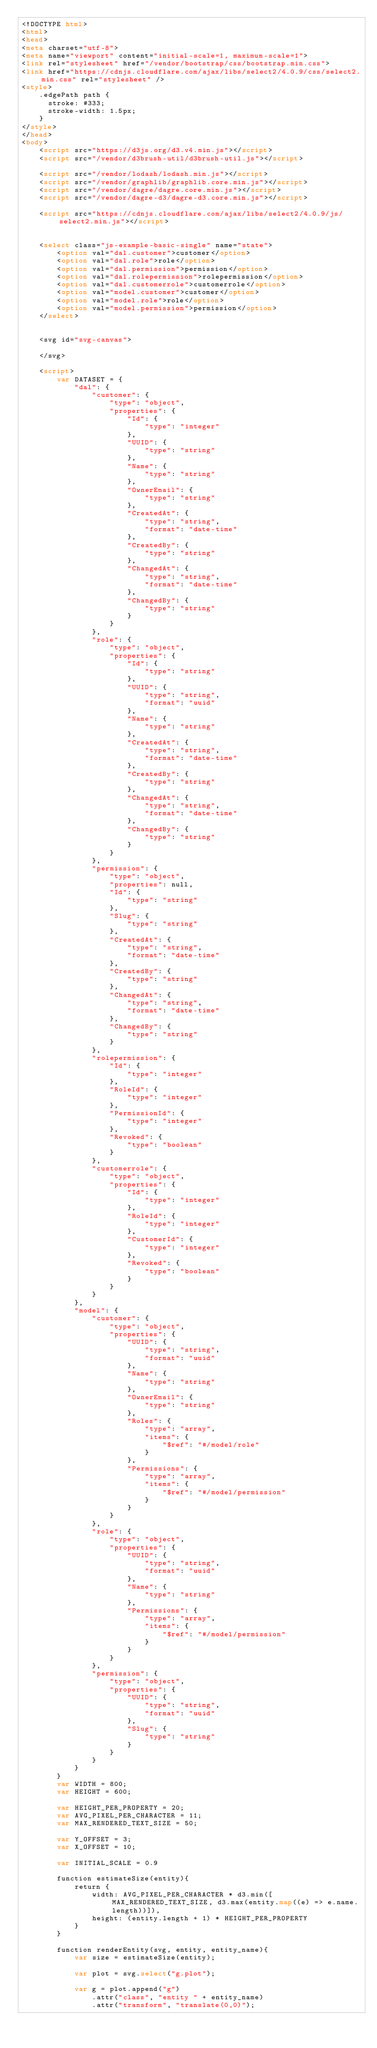<code> <loc_0><loc_0><loc_500><loc_500><_HTML_><!DOCTYPE html>
<html>
<head>
<meta charset="utf-8">
<meta name="viewport" content="initial-scale=1, maximum-scale=1">
<link rel="stylesheet" href="/vendor/bootstrap/css/bootstrap.min.css">
<link href="https://cdnjs.cloudflare.com/ajax/libs/select2/4.0.9/css/select2.min.css" rel="stylesheet" />
<style>
	.edgePath path {
	  stroke: #333;
	  stroke-width: 1.5px;
	}
</style>
</head>
<body>
	<script src="https://d3js.org/d3.v4.min.js"></script>
	<script src="/vendor/d3brush-util/d3brush-util.js"></script>

	<script src="/vendor/lodash/lodash.min.js"></script>
	<script src="/vendor/graphlib/graphlib.core.min.js"></script>
	<script src="/vendor/dagre/dagre.core.min.js"></script>
	<script src="/vendor/dagre-d3/dagre-d3.core.min.js"></script>

	<script src="https://cdnjs.cloudflare.com/ajax/libs/select2/4.0.9/js/select2.min.js"></script>


	<select class="js-example-basic-single" name="state">
		<option val="dal.customer">customer</option>
		<option val="dal.role">role</option>
		<option val="dal.permission">permission</option>
		<option val="dal.rolepermission">rolepermission</option>
		<option val="dal.customerrole">customerrole</option>
		<option val="model.customer">customer</option>
		<option val="model.role">role</option>
		<option val="model.permission">permission</option>
	</select>

	
	<svg id="svg-canvas">
		
	</svg>
	
	<script>
		var DATASET = {
		    "dal": {
		        "customer": {
		            "type": "object",
		            "properties": {
		                "Id": {
		                    "type": "integer"
		                },
		                "UUID": {
		                    "type": "string"
		                },
		                "Name": {
		                    "type": "string"
		                },
		                "OwnerEmail": {
		                    "type": "string"
		                },
		                "CreatedAt": {
		                    "type": "string",
		                    "format": "date-time"
		                },
		                "CreatedBy": {
		                    "type": "string"
		                },
		                "ChangedAt": {
		                    "type": "string",
		                    "format": "date-time"
		                },
		                "ChangedBy": {
		                    "type": "string"
		                }
		            }
		        },
		        "role": {
		            "type": "object",
		            "properties": {
		                "Id": {
		                    "type": "string"
		                },
		                "UUID": {
		                    "type": "string",
		                    "format": "uuid"
		                },
		                "Name": {
		                    "type": "string"
		                },
		                "CreatedAt": {
		                    "type": "string",
		                    "format": "date-time"
		                },
		                "CreatedBy": {
		                    "type": "string"
		                },
		                "ChangedAt": {
		                    "type": "string",
		                    "format": "date-time"
		                },
		                "ChangedBy": {
		                    "type": "string"
		                }
		            }
		        },
		        "permission": {
		            "type": "object",
		            "properties": null,
		            "Id": {
		                "type": "string"
		            },
		            "Slug": {
		                "type": "string"
		            },
		            "CreatedAt": {
		                "type": "string",
		                "format": "date-time"
		            },
		            "CreatedBy": {
		                "type": "string"
		            },
		            "ChangedAt": {
		                "type": "string",
		                "format": "date-time"
		            },
		            "ChangedBy": {
		                "type": "string"
		            }
		        },
		        "rolepermission": {
		            "Id": {
		                "type": "integer"
		            },
		            "RoleId": {
		                "type": "integer"
		            },
		            "PermissionId": {
		                "type": "integer"
		            },
		            "Revoked": {
		                "type": "boolean"
		            }
		        },
		        "customerrole": {
		            "type": "object",
		            "properties": {
		                "Id": {
		                    "type": "integer"
		                },
		                "RoleId": {
		                    "type": "integer"
		                },
		                "CustomerId": {
		                    "type": "integer"
		                },
		                "Revoked": {
		                    "type": "boolean"
		                }
		            }
		        }
		    },
		    "model": {
		        "customer": {
		            "type": "object",
		            "properties": {
		                "UUID": {
		                    "type": "string",
		                    "format": "uuid"
		                },
		                "Name": {
		                    "type": "string"
		                },
		                "OwnerEmail": {
		                    "type": "string"
		                },
		                "Roles": {
		                    "type": "array",
		                    "items": {
		                        "$ref": "#/model/role"
		                    }
		                },
		                "Permissions": {
		                    "type": "array",
		                    "items": {
		                        "$ref": "#/model/permission"
		                    }
		                }
		            }
		        },
		        "role": {
		            "type": "object",
		            "properties": {
		                "UUID": {
		                    "type": "string",
		                    "format": "uuid"
		                },
		                "Name": {
		                    "type": "string"
		                },
		                "Permissions": {
		                    "type": "array",
		                    "items": {
		                        "$ref": "#/model/permission"
		                    }
		                }
		            }
		        },
		        "permission": {
		            "type": "object",
		            "properties": {
		                "UUID": {
		                    "type": "string",
		                    "format": "uuid"
		                },
		                "Slug": {
		                    "type": "string"
		                }
		            }
		        }
		    }
		}
		var WIDTH = 800;
		var HEIGHT = 600;

		var HEIGHT_PER_PROPERTY = 20;
		var AVG_PIXEL_PER_CHARACTER = 11;
		var MAX_RENDERED_TEXT_SIZE = 50;

		var Y_OFFSET = 3;
		var X_OFFSET = 10;

		var INITIAL_SCALE = 0.9

		function estimateSize(entity){
			return {
				width: AVG_PIXEL_PER_CHARACTER * d3.min([MAX_RENDERED_TEXT_SIZE, d3.max(entity.map((e) => e.name.length))]),
				height: (entity.length + 1) * HEIGHT_PER_PROPERTY 
			}
		}

		function renderEntity(svg, entity, entity_name){
			var size = estimateSize(entity);

			var plot = svg.select("g.plot");

			var g = plot.append("g")
				.attr("class", "entity " + entity_name)
				.attr("transform", "translate(0,0)");
</code> 